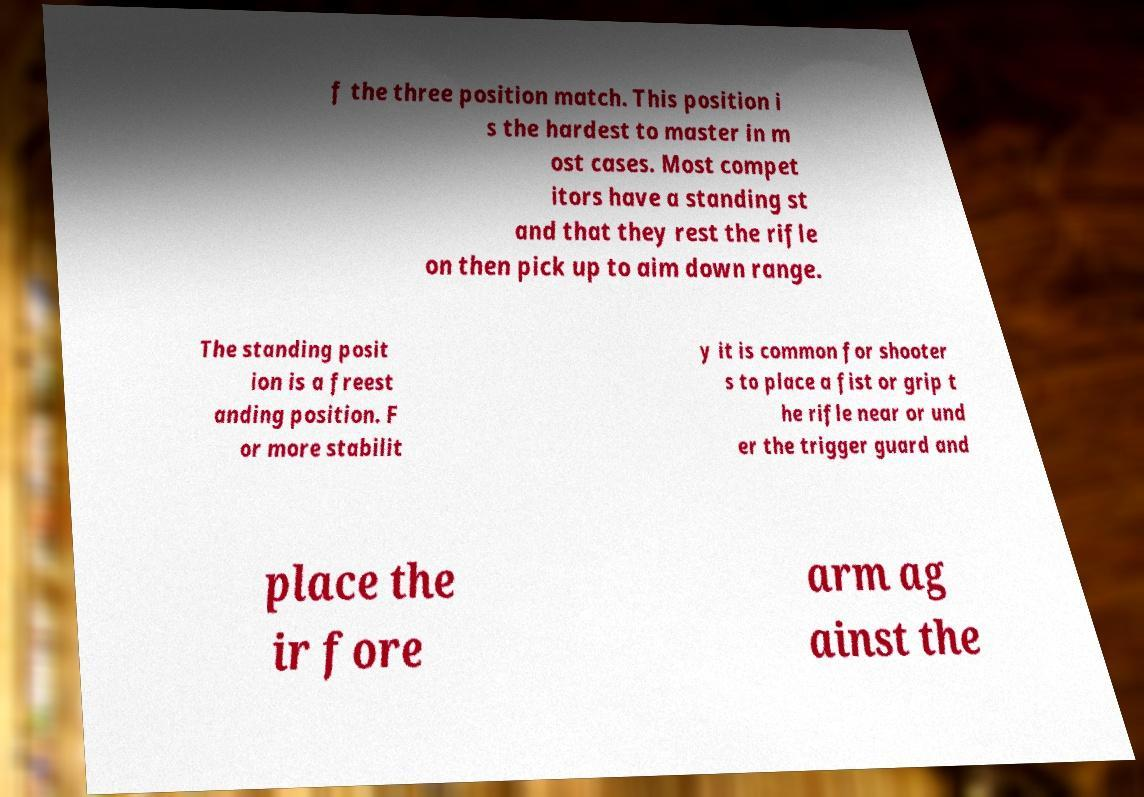For documentation purposes, I need the text within this image transcribed. Could you provide that? f the three position match. This position i s the hardest to master in m ost cases. Most compet itors have a standing st and that they rest the rifle on then pick up to aim down range. The standing posit ion is a freest anding position. F or more stabilit y it is common for shooter s to place a fist or grip t he rifle near or und er the trigger guard and place the ir fore arm ag ainst the 